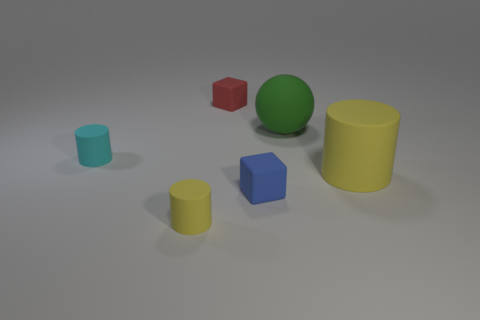Add 3 tiny red things. How many objects exist? 9 Subtract all blocks. How many objects are left? 4 Subtract 0 yellow cubes. How many objects are left? 6 Subtract all small red things. Subtract all blue matte cubes. How many objects are left? 4 Add 1 tiny red rubber blocks. How many tiny red rubber blocks are left? 2 Add 4 small gray shiny balls. How many small gray shiny balls exist? 4 